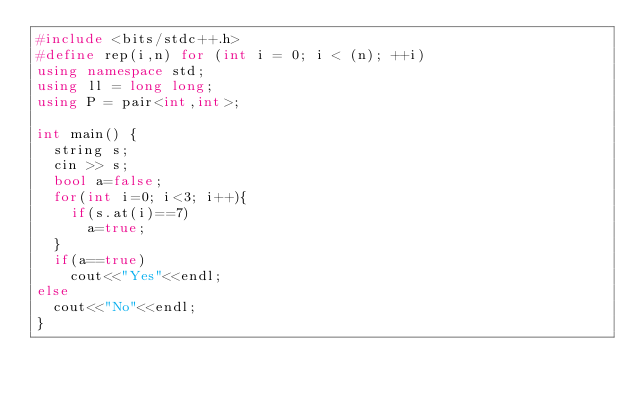Convert code to text. <code><loc_0><loc_0><loc_500><loc_500><_C++_>#include <bits/stdc++.h>
#define rep(i,n) for (int i = 0; i < (n); ++i)
using namespace std;
using ll = long long;
using P = pair<int,int>;

int main() {
  string s;
  cin >> s;
  bool a=false;
  for(int i=0; i<3; i++){
    if(s.at(i)==7)
      a=true;
  }
  if(a==true)
    cout<<"Yes"<<endl;
else
  cout<<"No"<<endl;
}
</code> 